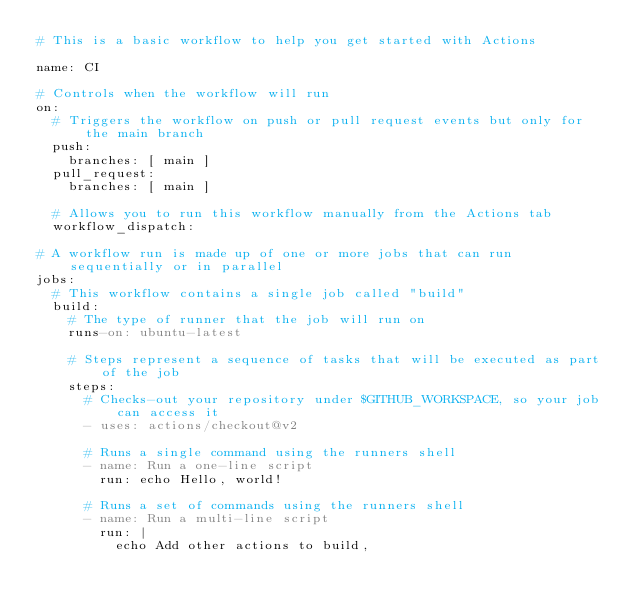Convert code to text. <code><loc_0><loc_0><loc_500><loc_500><_YAML_># This is a basic workflow to help you get started with Actions

name: CI

# Controls when the workflow will run
on:
  # Triggers the workflow on push or pull request events but only for the main branch
  push:
    branches: [ main ]
  pull_request:
    branches: [ main ]

  # Allows you to run this workflow manually from the Actions tab
  workflow_dispatch:

# A workflow run is made up of one or more jobs that can run sequentially or in parallel
jobs:
  # This workflow contains a single job called "build"
  build:
    # The type of runner that the job will run on
    runs-on: ubuntu-latest

    # Steps represent a sequence of tasks that will be executed as part of the job
    steps:
      # Checks-out your repository under $GITHUB_WORKSPACE, so your job can access it
      - uses: actions/checkout@v2

      # Runs a single command using the runners shell
      - name: Run a one-line script
        run: echo Hello, world!

      # Runs a set of commands using the runners shell
      - name: Run a multi-line script
        run: |
          echo Add other actions to build,</code> 